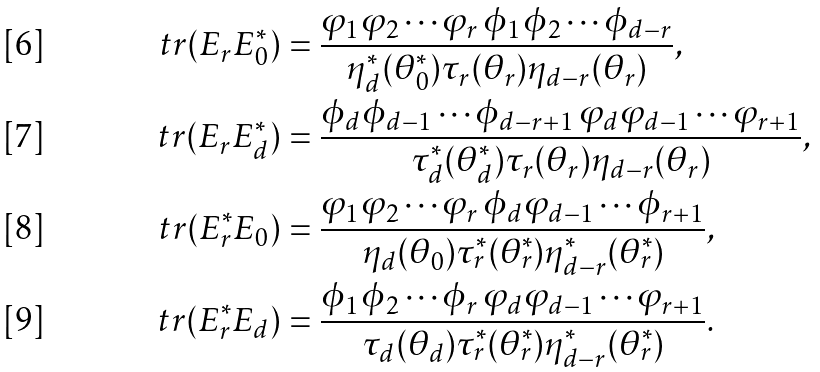Convert formula to latex. <formula><loc_0><loc_0><loc_500><loc_500>\ t r ( E _ { r } E ^ { * } _ { 0 } ) & = \frac { \varphi _ { 1 } \varphi _ { 2 } \cdots \varphi _ { r } \, \phi _ { 1 } \phi _ { 2 } \cdots \phi _ { d - r } } { \eta ^ { * } _ { d } ( \theta ^ { * } _ { 0 } ) \tau _ { r } ( \theta _ { r } ) \eta _ { d - r } ( \theta _ { r } ) } , \\ \ t r ( E _ { r } E ^ { * } _ { d } ) & = \frac { \phi _ { d } \phi _ { d - 1 } \cdots \phi _ { d - r + 1 } \, \varphi _ { d } \varphi _ { d - 1 } \cdots \varphi _ { r + 1 } } { \tau ^ { * } _ { d } ( \theta ^ { * } _ { d } ) \tau _ { r } ( \theta _ { r } ) \eta _ { d - r } ( \theta _ { r } ) } , \\ \ t r ( E ^ { * } _ { r } E _ { 0 } ) & = \frac { \varphi _ { 1 } \varphi _ { 2 } \cdots \varphi _ { r } \, \phi _ { d } \varphi _ { d - 1 } \cdots \phi _ { r + 1 } } { \eta _ { d } ( \theta _ { 0 } ) \tau ^ { * } _ { r } ( \theta ^ { * } _ { r } ) \eta ^ { * } _ { d - r } ( \theta ^ { * } _ { r } ) } , \\ \ t r ( E ^ { * } _ { r } E _ { d } ) & = \frac { \phi _ { 1 } \phi _ { 2 } \cdots \phi _ { r } \, \varphi _ { d } \varphi _ { d - 1 } \cdots \varphi _ { r + 1 } } { \tau _ { d } ( \theta _ { d } ) \tau ^ { * } _ { r } ( \theta ^ { * } _ { r } ) \eta ^ { * } _ { d - r } ( \theta ^ { * } _ { r } ) } .</formula> 